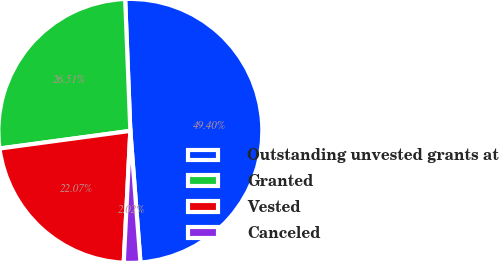Convert chart to OTSL. <chart><loc_0><loc_0><loc_500><loc_500><pie_chart><fcel>Outstanding unvested grants at<fcel>Granted<fcel>Vested<fcel>Canceled<nl><fcel>49.4%<fcel>26.51%<fcel>22.07%<fcel>2.02%<nl></chart> 